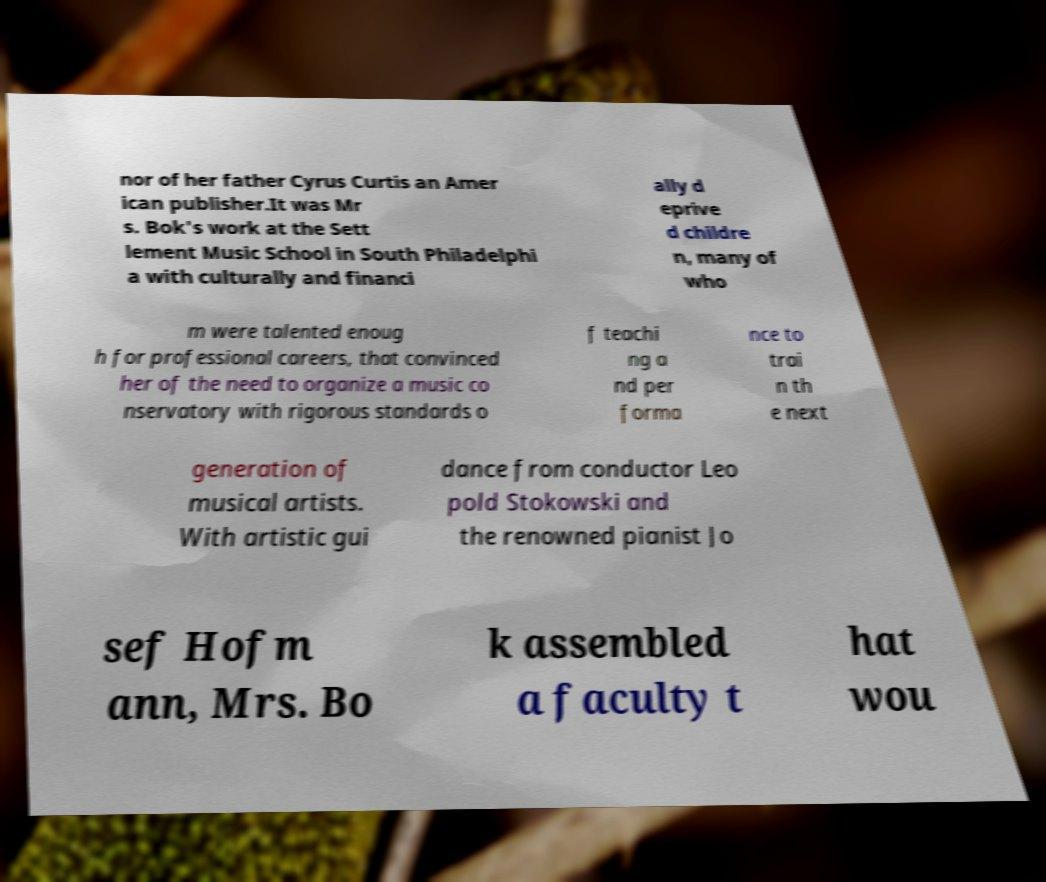Please read and relay the text visible in this image. What does it say? nor of her father Cyrus Curtis an Amer ican publisher.It was Mr s. Bok's work at the Sett lement Music School in South Philadelphi a with culturally and financi ally d eprive d childre n, many of who m were talented enoug h for professional careers, that convinced her of the need to organize a music co nservatory with rigorous standards o f teachi ng a nd per forma nce to trai n th e next generation of musical artists. With artistic gui dance from conductor Leo pold Stokowski and the renowned pianist Jo sef Hofm ann, Mrs. Bo k assembled a faculty t hat wou 